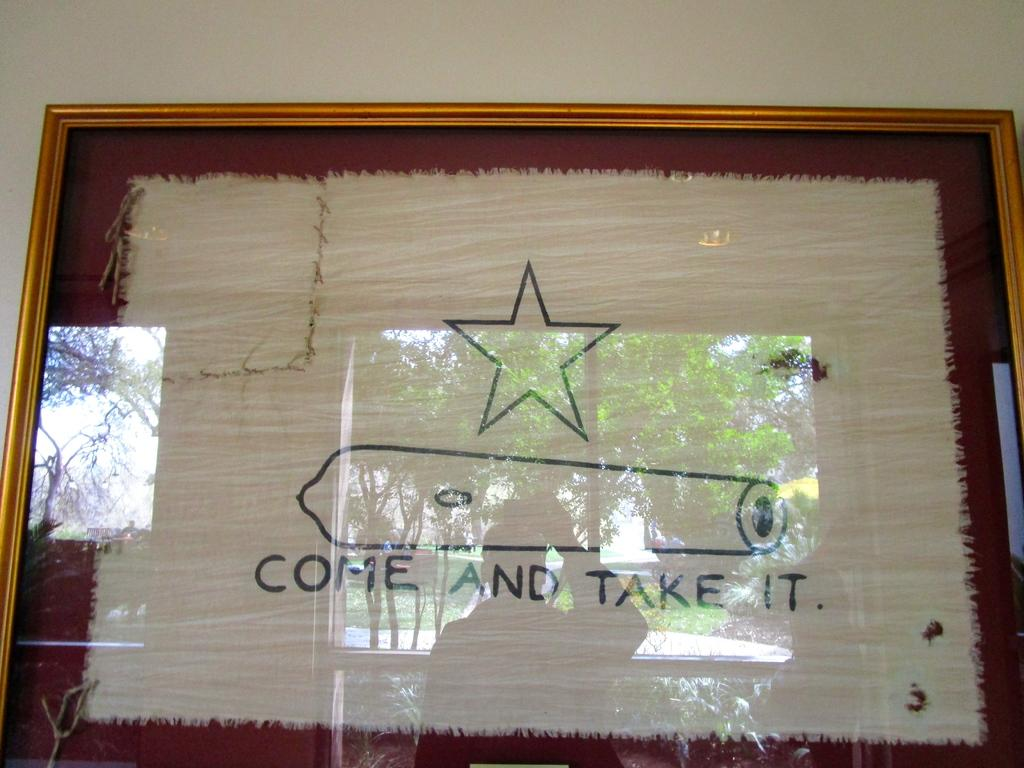What is the main object in the image? There is a frame in the image. What is covering the frame? The frame is covered with a glass. What can be seen behind the glass? There are two images and a text behind the glass. What type of creature is depicted in the image? There is no creature depicted in the image; it contains two images and a text behind the glass. 